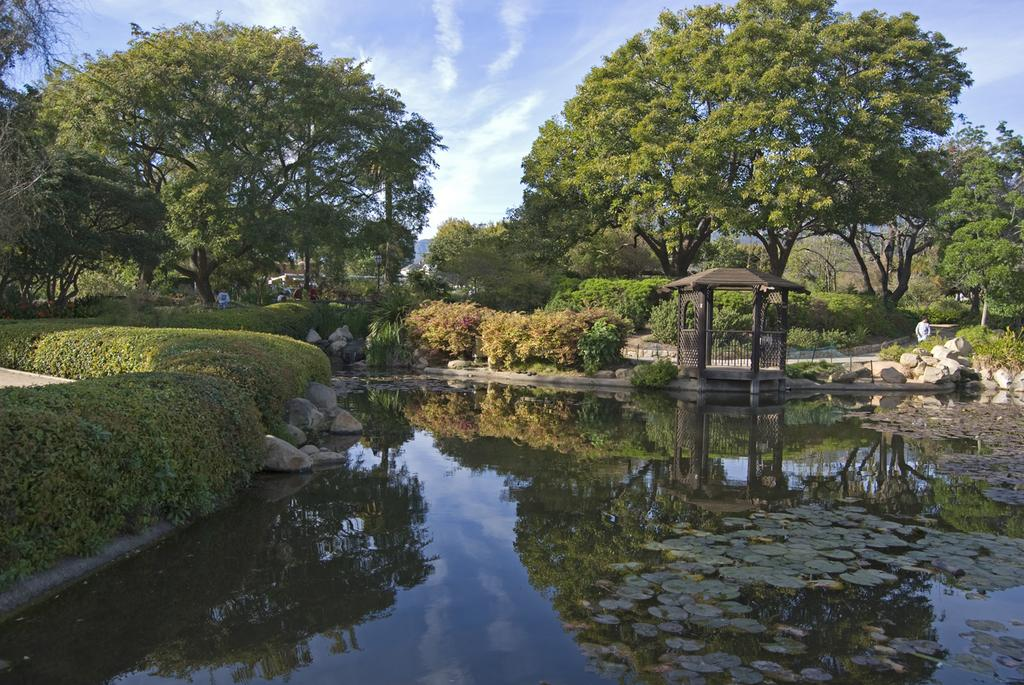What type of natural feature can be seen in the image? There is a lake in the image. What objects are present near the lake? There are stones, bushes, and trees in the image. What are the people in the image doing? There are persons walking on a road in the image. What is visible in the background of the image? The sky is visible in the background of the image, and there are clouds in the sky. Where is the drawer located in the image? There is no drawer present in the image. How many clocks can be seen hanging from the trees in the image? There are no clocks hanging from the trees in the image; it features a lake, stones, bushes, trees, people walking, and a sky with clouds. 